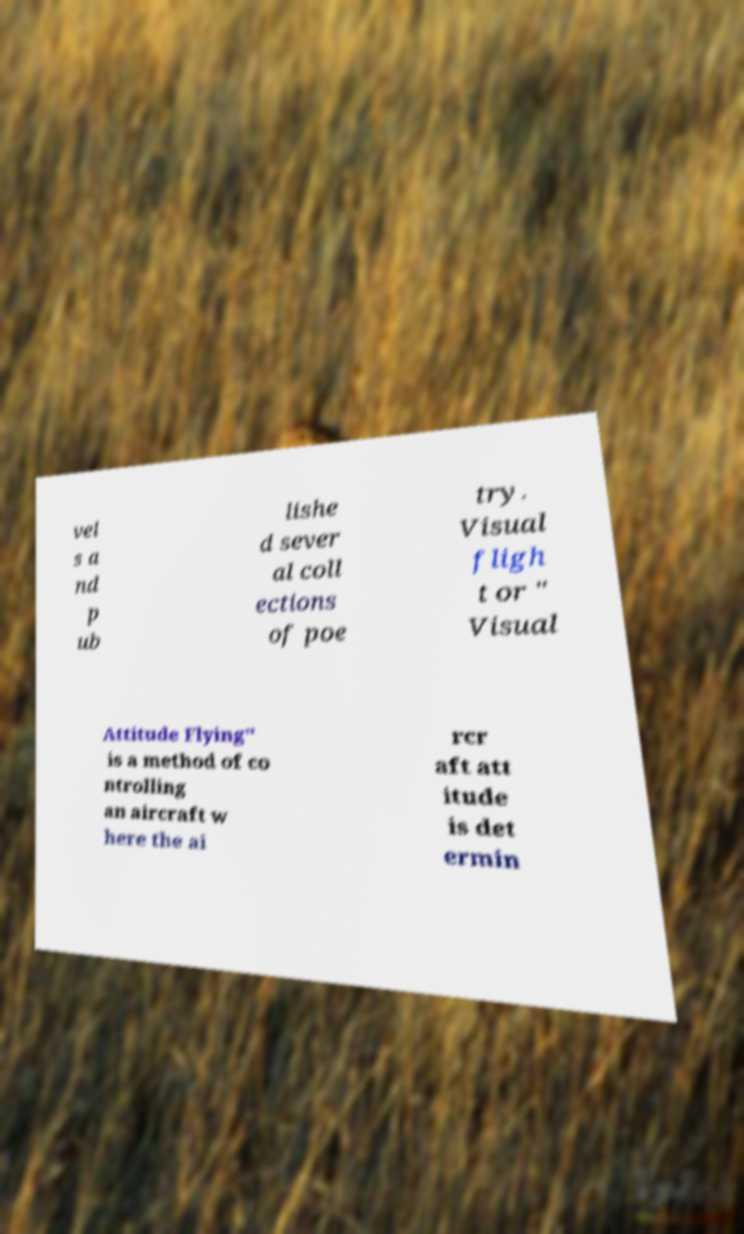Please read and relay the text visible in this image. What does it say? vel s a nd p ub lishe d sever al coll ections of poe try. Visual fligh t or " Visual Attitude Flying" is a method of co ntrolling an aircraft w here the ai rcr aft att itude is det ermin 